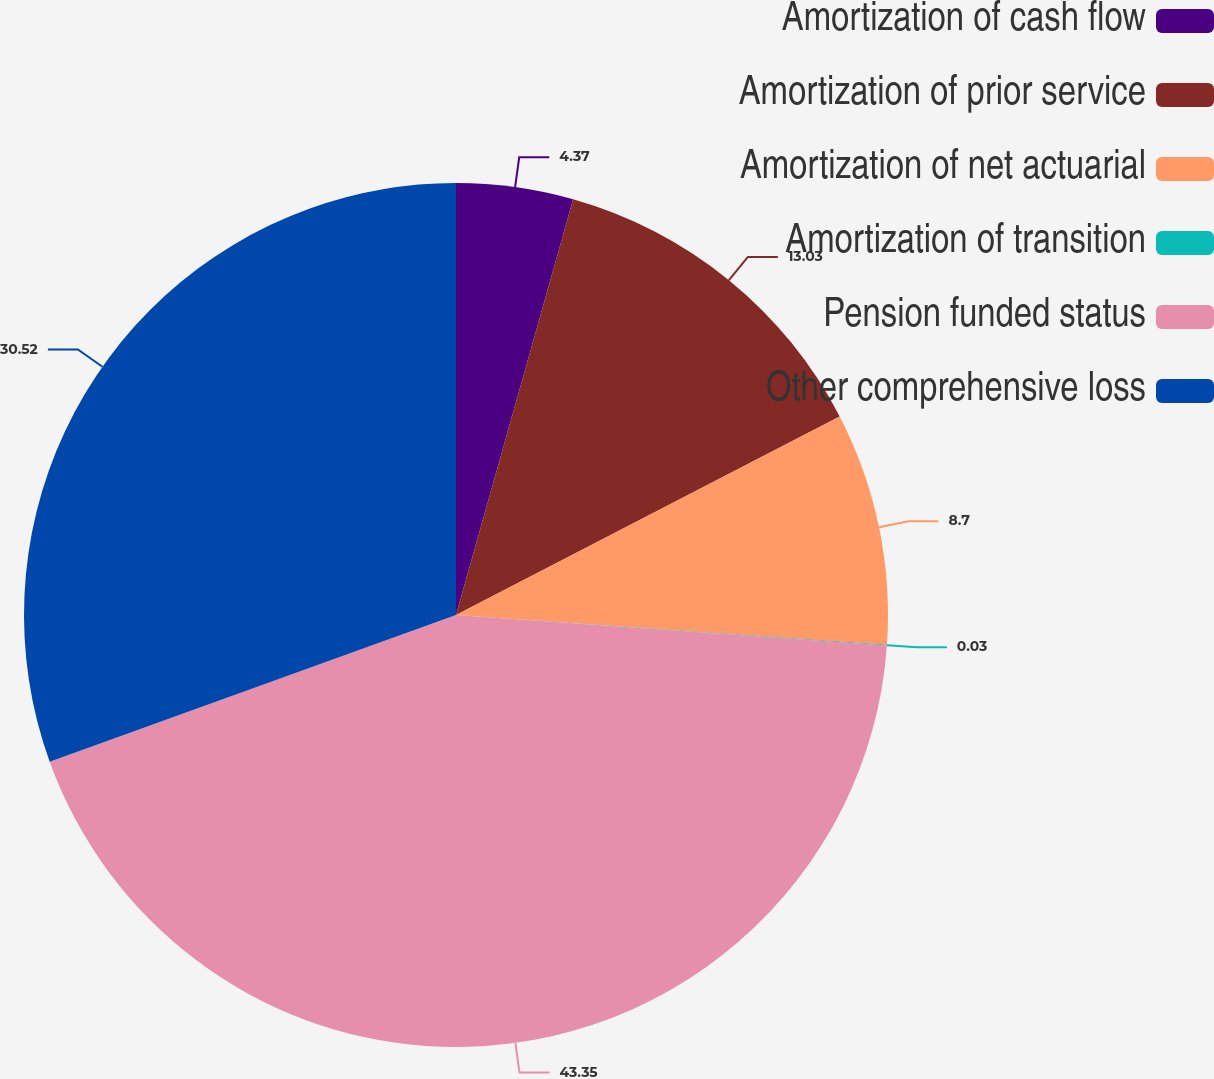Convert chart. <chart><loc_0><loc_0><loc_500><loc_500><pie_chart><fcel>Amortization of cash flow<fcel>Amortization of prior service<fcel>Amortization of net actuarial<fcel>Amortization of transition<fcel>Pension funded status<fcel>Other comprehensive loss<nl><fcel>4.37%<fcel>13.03%<fcel>8.7%<fcel>0.03%<fcel>43.36%<fcel>30.52%<nl></chart> 